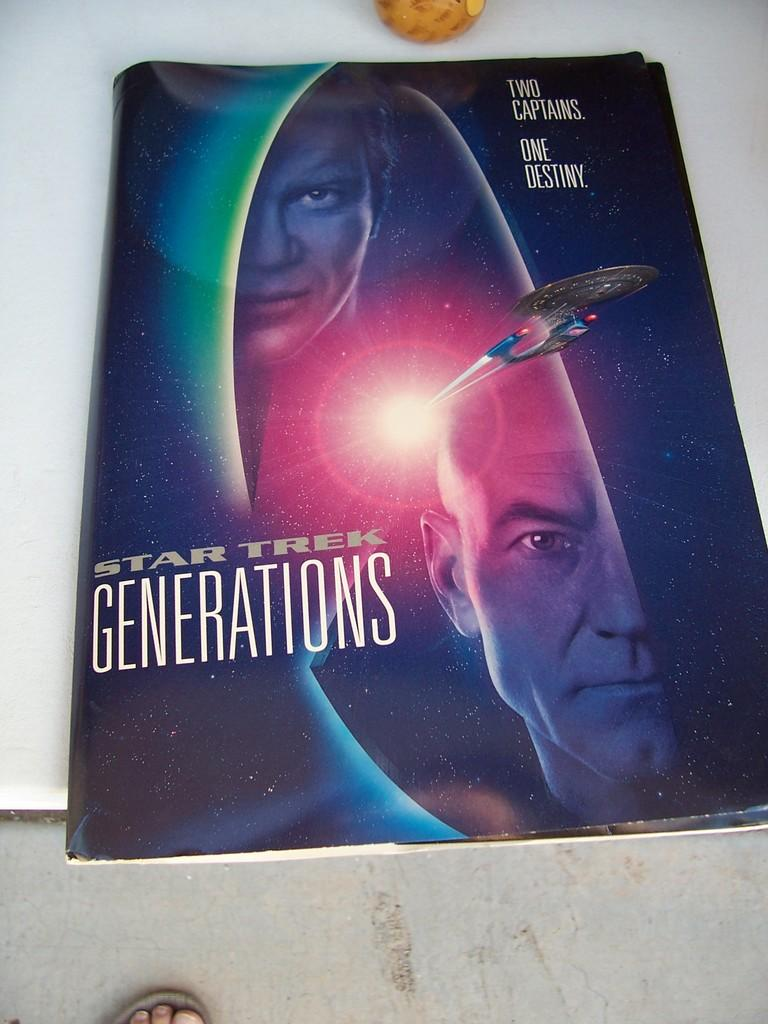What can be seen in the foreground of the image? There is a leg of a person in the foreground of the image. What is the main object in the center of the image? There is a book with pictures and text in the center of the image. What is placed on the surface of the book? There is an object placed on the surface of the book. What type of furniture can be seen in the background of the image? There is no furniture visible in the image; it only shows a leg of a person, a book, and an object placed on the book. 